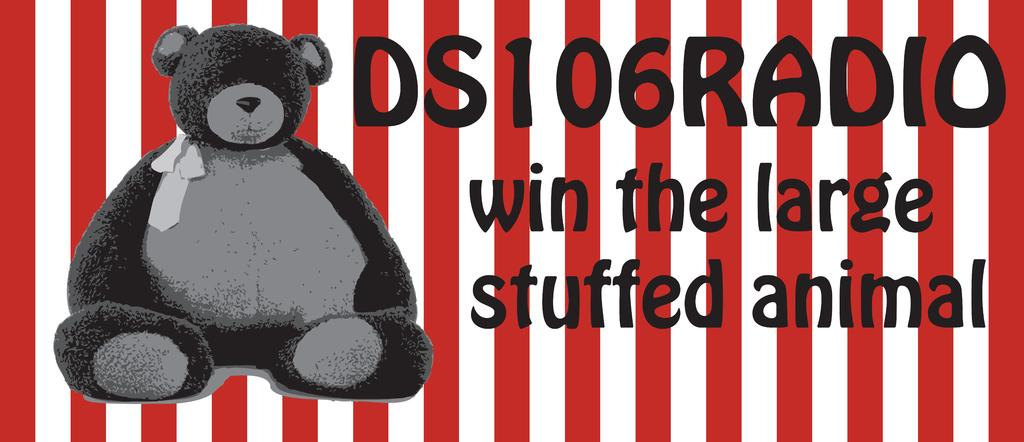What type of visual is the image? The image is a poster. What is depicted on the poster? There is a picture of a teddy bear on the poster. Are there any words on the poster? Yes, there is text on the poster. What colors are used for the background of the poster? The background of the poster has white and red stripes. What type of songs can be heard in the background of the poster? There are no songs present in the image, as it is a static poster. How many rabbits are visible on the poster? There are no rabbits depicted on the poster; it features a picture of a teddy bear. What type of dinosaur is shown interacting with the teddy bear on the poster? There is no dinosaur present on the poster; it only features a teddy bear and text. 